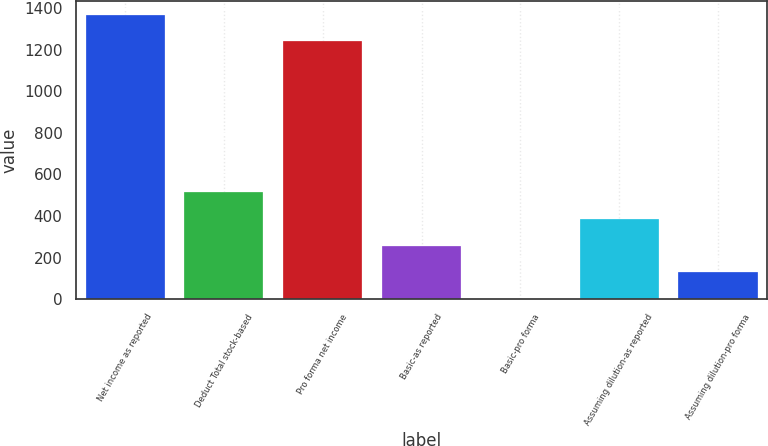Convert chart to OTSL. <chart><loc_0><loc_0><loc_500><loc_500><bar_chart><fcel>Net income as reported<fcel>Deduct Total stock-based<fcel>Pro forma net income<fcel>Basic-as reported<fcel>Basic-pro forma<fcel>Assuming dilution-as reported<fcel>Assuming dilution-pro forma<nl><fcel>1366.96<fcel>513.28<fcel>1239<fcel>257.36<fcel>1.44<fcel>385.32<fcel>129.4<nl></chart> 